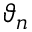<formula> <loc_0><loc_0><loc_500><loc_500>\vartheta _ { n }</formula> 